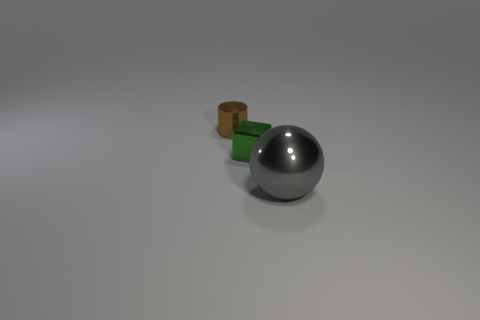Add 3 brown objects. How many objects exist? 6 Subtract all balls. How many objects are left? 2 Add 3 cubes. How many cubes exist? 4 Subtract 0 brown blocks. How many objects are left? 3 Subtract all large red cylinders. Subtract all gray metal spheres. How many objects are left? 2 Add 2 small green blocks. How many small green blocks are left? 3 